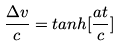Convert formula to latex. <formula><loc_0><loc_0><loc_500><loc_500>\frac { \Delta v } { c } = t a n h [ \frac { a t } { c } ]</formula> 